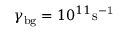Convert formula to latex. <formula><loc_0><loc_0><loc_500><loc_500>\gamma _ { b g } = 1 0 ^ { 1 1 } s ^ { - 1 }</formula> 